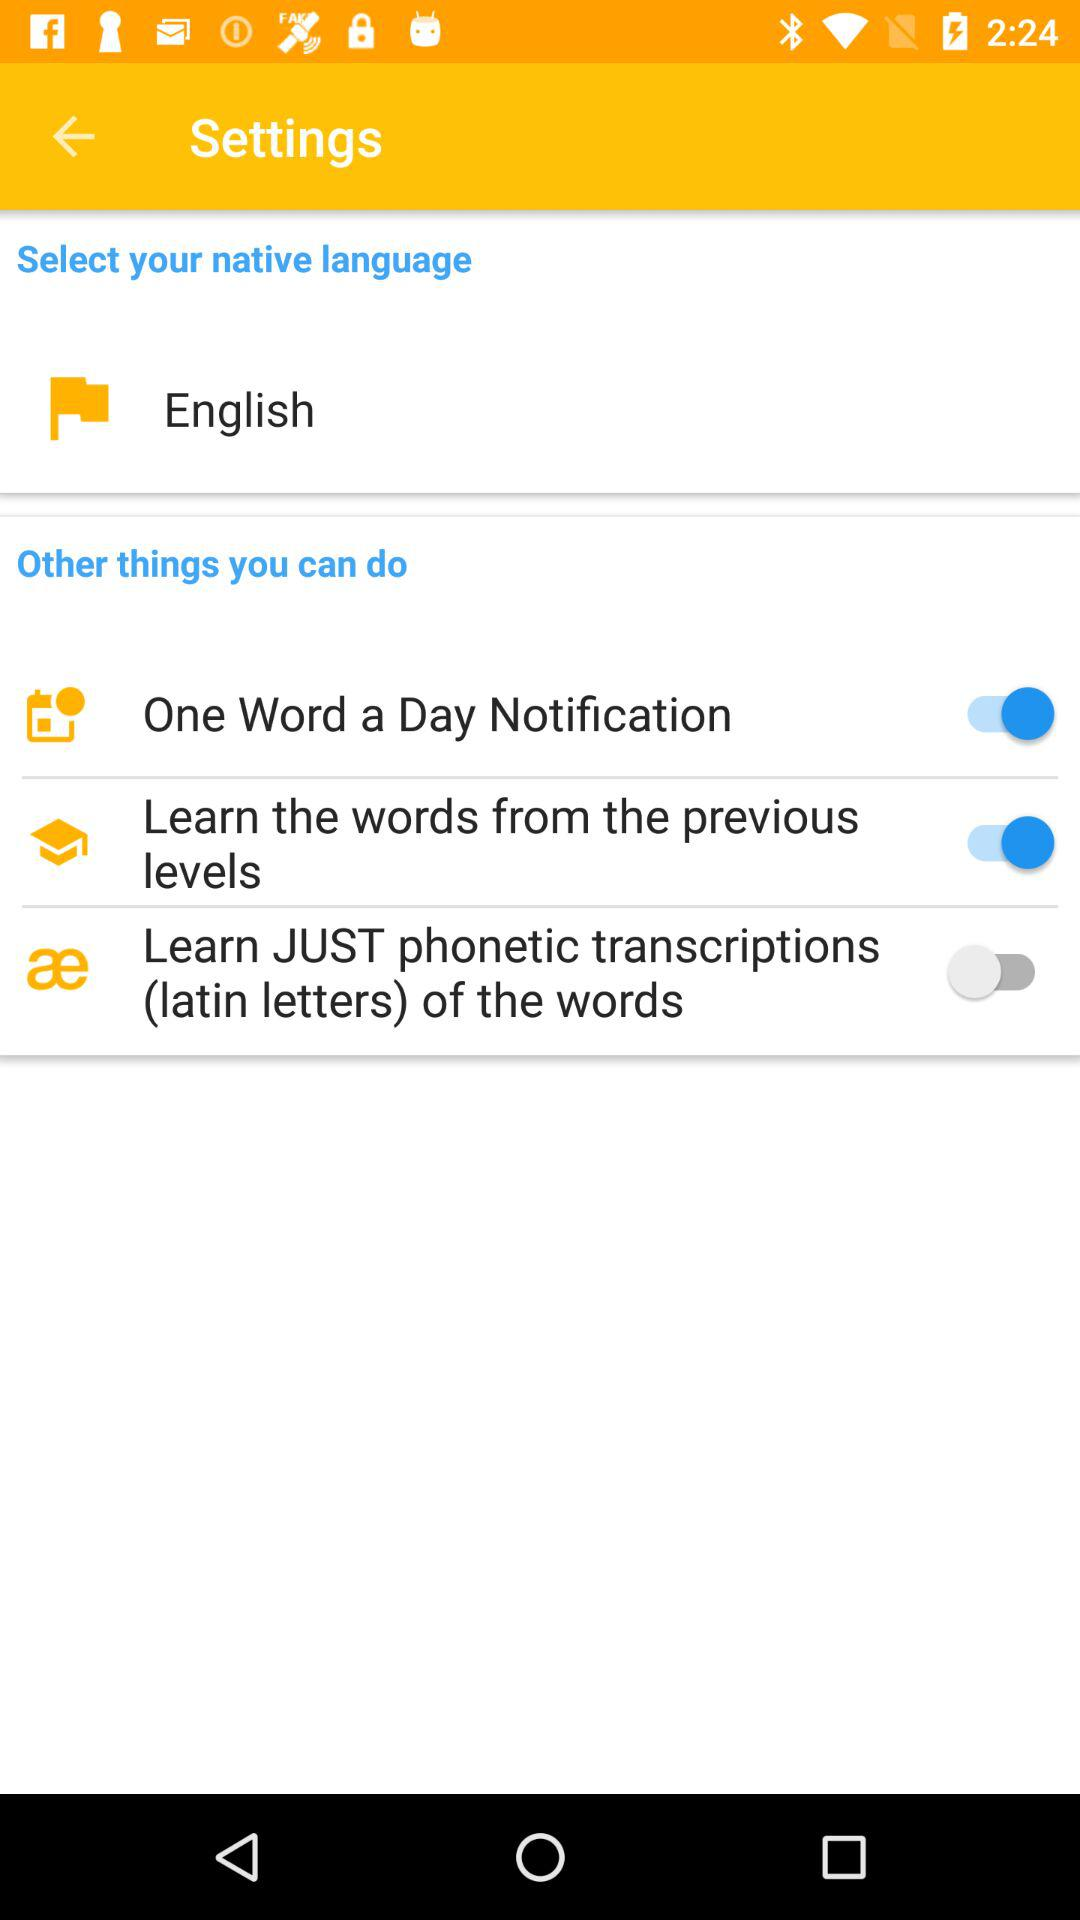How many items are in the Other things you can do section?
Answer the question using a single word or phrase. 3 